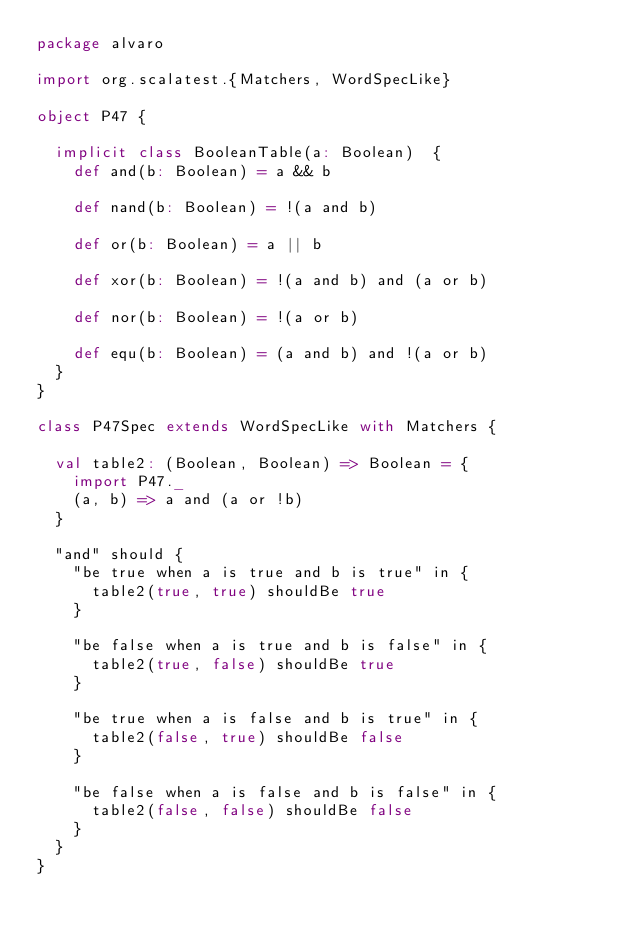Convert code to text. <code><loc_0><loc_0><loc_500><loc_500><_Scala_>package alvaro

import org.scalatest.{Matchers, WordSpecLike}

object P47 {

  implicit class BooleanTable(a: Boolean)  {
    def and(b: Boolean) = a && b

    def nand(b: Boolean) = !(a and b)

    def or(b: Boolean) = a || b

    def xor(b: Boolean) = !(a and b) and (a or b)

    def nor(b: Boolean) = !(a or b)

    def equ(b: Boolean) = (a and b) and !(a or b)
  }
}

class P47Spec extends WordSpecLike with Matchers {

  val table2: (Boolean, Boolean) => Boolean = {
    import P47._
    (a, b) => a and (a or !b)
  }

  "and" should {
    "be true when a is true and b is true" in {
      table2(true, true) shouldBe true
    }

    "be false when a is true and b is false" in {
      table2(true, false) shouldBe true
    }

    "be true when a is false and b is true" in {
      table2(false, true) shouldBe false
    }

    "be false when a is false and b is false" in {
      table2(false, false) shouldBe false
    }
  }
}
</code> 